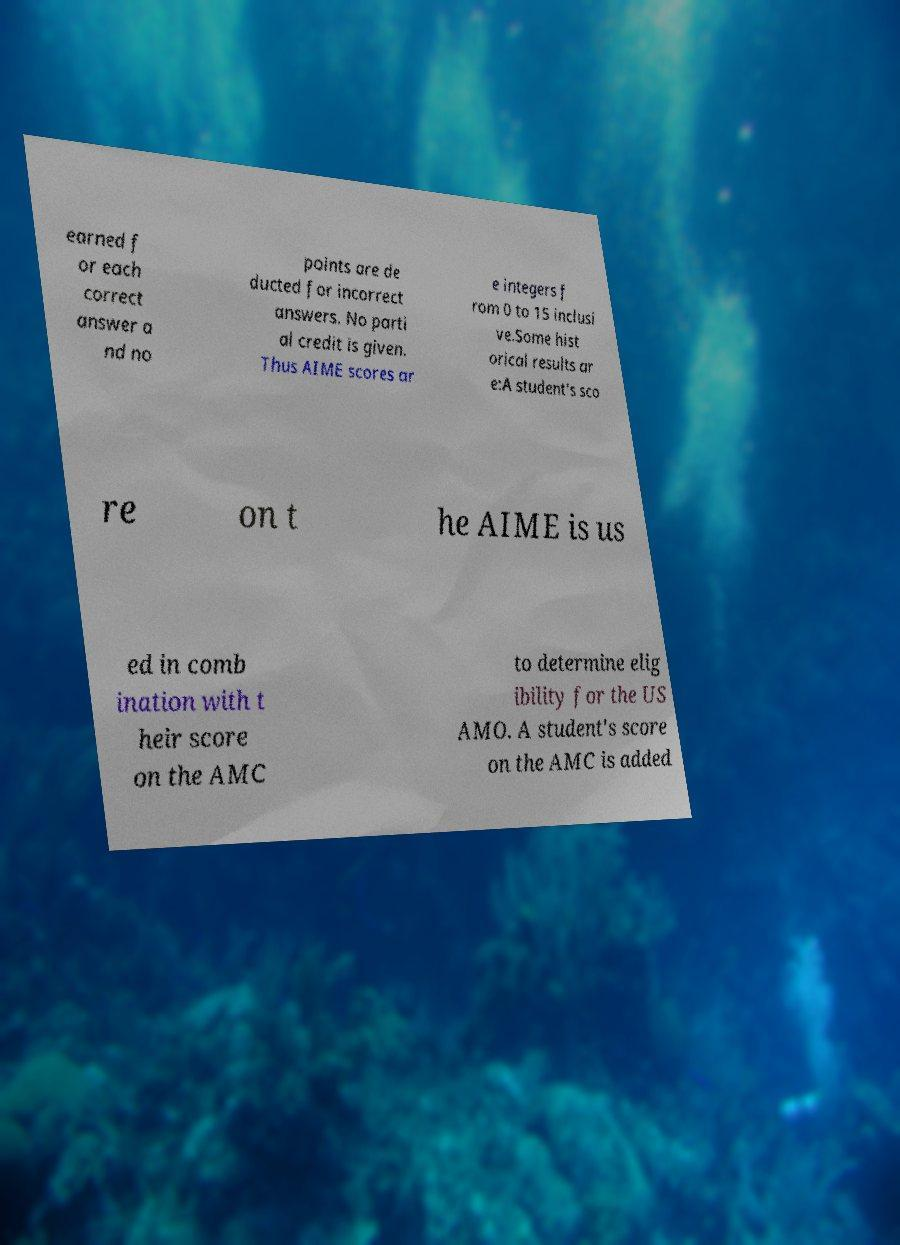Please read and relay the text visible in this image. What does it say? earned f or each correct answer a nd no points are de ducted for incorrect answers. No parti al credit is given. Thus AIME scores ar e integers f rom 0 to 15 inclusi ve.Some hist orical results ar e:A student's sco re on t he AIME is us ed in comb ination with t heir score on the AMC to determine elig ibility for the US AMO. A student's score on the AMC is added 